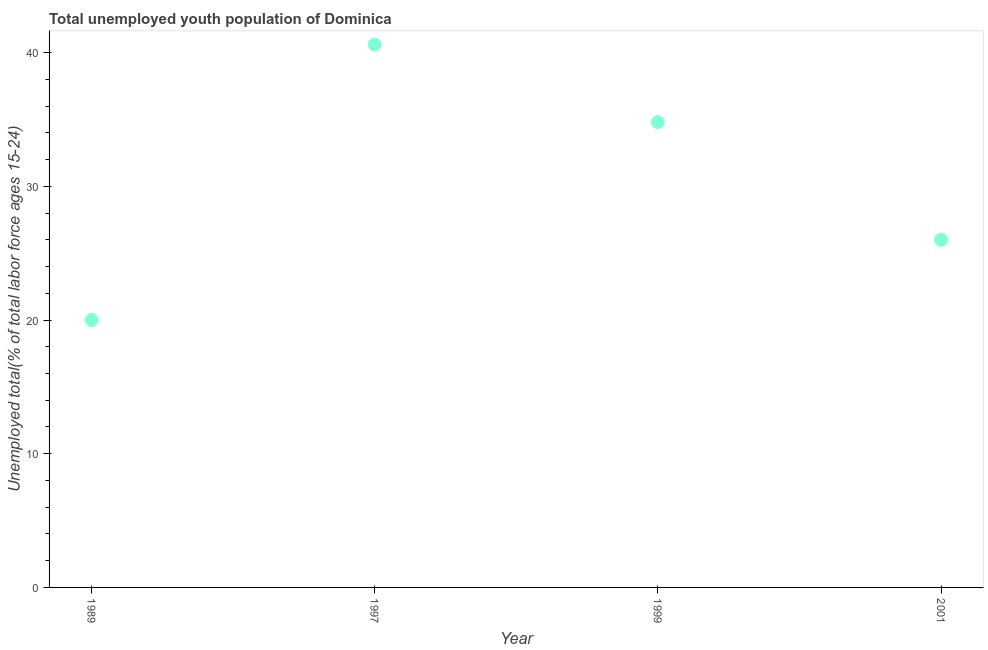What is the unemployed youth in 2001?
Ensure brevity in your answer.  26. Across all years, what is the maximum unemployed youth?
Offer a very short reply. 40.6. Across all years, what is the minimum unemployed youth?
Make the answer very short. 20. In which year was the unemployed youth minimum?
Provide a succinct answer. 1989. What is the sum of the unemployed youth?
Keep it short and to the point. 121.4. What is the difference between the unemployed youth in 1997 and 2001?
Provide a short and direct response. 14.6. What is the average unemployed youth per year?
Offer a very short reply. 30.35. What is the median unemployed youth?
Ensure brevity in your answer.  30.4. Do a majority of the years between 2001 and 1989 (inclusive) have unemployed youth greater than 32 %?
Ensure brevity in your answer.  Yes. What is the ratio of the unemployed youth in 1989 to that in 1997?
Ensure brevity in your answer.  0.49. Is the unemployed youth in 1997 less than that in 1999?
Your answer should be very brief. No. What is the difference between the highest and the second highest unemployed youth?
Give a very brief answer. 5.8. What is the difference between the highest and the lowest unemployed youth?
Your answer should be compact. 20.6. Does the unemployed youth monotonically increase over the years?
Offer a very short reply. No. How many dotlines are there?
Give a very brief answer. 1. Are the values on the major ticks of Y-axis written in scientific E-notation?
Give a very brief answer. No. Does the graph contain any zero values?
Your answer should be compact. No. Does the graph contain grids?
Give a very brief answer. No. What is the title of the graph?
Offer a terse response. Total unemployed youth population of Dominica. What is the label or title of the Y-axis?
Make the answer very short. Unemployed total(% of total labor force ages 15-24). What is the Unemployed total(% of total labor force ages 15-24) in 1997?
Offer a terse response. 40.6. What is the Unemployed total(% of total labor force ages 15-24) in 1999?
Offer a very short reply. 34.8. What is the Unemployed total(% of total labor force ages 15-24) in 2001?
Offer a very short reply. 26. What is the difference between the Unemployed total(% of total labor force ages 15-24) in 1989 and 1997?
Ensure brevity in your answer.  -20.6. What is the difference between the Unemployed total(% of total labor force ages 15-24) in 1989 and 1999?
Your answer should be compact. -14.8. What is the difference between the Unemployed total(% of total labor force ages 15-24) in 1989 and 2001?
Keep it short and to the point. -6. What is the difference between the Unemployed total(% of total labor force ages 15-24) in 1997 and 2001?
Your answer should be very brief. 14.6. What is the ratio of the Unemployed total(% of total labor force ages 15-24) in 1989 to that in 1997?
Offer a terse response. 0.49. What is the ratio of the Unemployed total(% of total labor force ages 15-24) in 1989 to that in 1999?
Provide a short and direct response. 0.57. What is the ratio of the Unemployed total(% of total labor force ages 15-24) in 1989 to that in 2001?
Offer a very short reply. 0.77. What is the ratio of the Unemployed total(% of total labor force ages 15-24) in 1997 to that in 1999?
Offer a terse response. 1.17. What is the ratio of the Unemployed total(% of total labor force ages 15-24) in 1997 to that in 2001?
Provide a succinct answer. 1.56. What is the ratio of the Unemployed total(% of total labor force ages 15-24) in 1999 to that in 2001?
Provide a short and direct response. 1.34. 